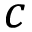<formula> <loc_0><loc_0><loc_500><loc_500>c</formula> 